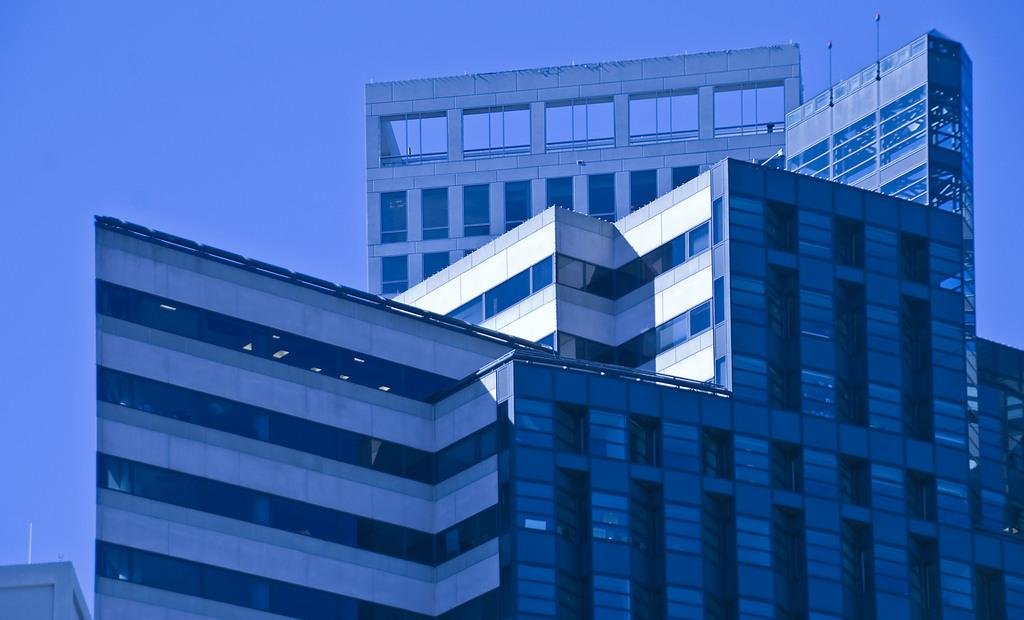What structure is present in the picture? There is a building in the picture. What type of windows does the building have? The building has glass windows. What is the condition of the sky in the picture? The sky is clear in the picture. How many bikes are parked in front of the building in the image? There is no information about bikes or any other vehicles in the image. Can you tell me how many marks are visible on the building's facade? There is no mention of any marks or patterns on the building's facade in the provided facts. 